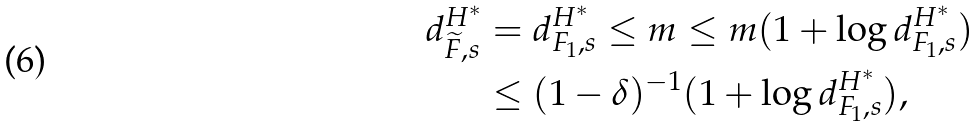Convert formula to latex. <formula><loc_0><loc_0><loc_500><loc_500>d ^ { H ^ { * } } _ { \widetilde { F } , s } & = d ^ { H ^ { * } } _ { F _ { 1 } , s } \leq m \leq m ( 1 + \log d ^ { H ^ { * } } _ { F _ { 1 } , s } ) \\ & \leq ( 1 - \delta ) ^ { - 1 } ( 1 + \log d ^ { H ^ { * } } _ { F _ { 1 } , s } ) ,</formula> 